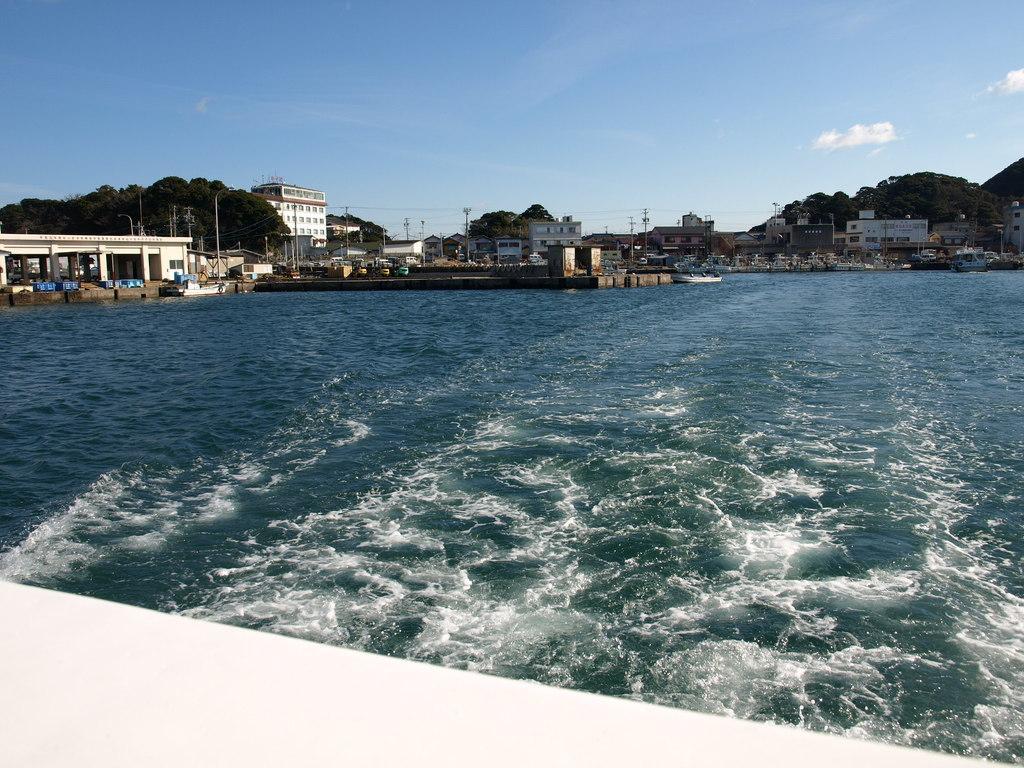Describe this image in one or two sentences. In this image I can see a water. Back I can see buildings,trees,light-poles and current poles. I can see mountains. The sky is in blue and white color. 